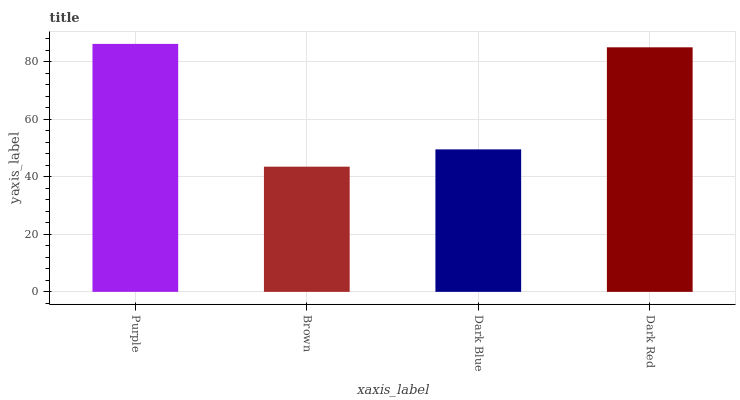Is Brown the minimum?
Answer yes or no. Yes. Is Purple the maximum?
Answer yes or no. Yes. Is Dark Blue the minimum?
Answer yes or no. No. Is Dark Blue the maximum?
Answer yes or no. No. Is Dark Blue greater than Brown?
Answer yes or no. Yes. Is Brown less than Dark Blue?
Answer yes or no. Yes. Is Brown greater than Dark Blue?
Answer yes or no. No. Is Dark Blue less than Brown?
Answer yes or no. No. Is Dark Red the high median?
Answer yes or no. Yes. Is Dark Blue the low median?
Answer yes or no. Yes. Is Brown the high median?
Answer yes or no. No. Is Dark Red the low median?
Answer yes or no. No. 